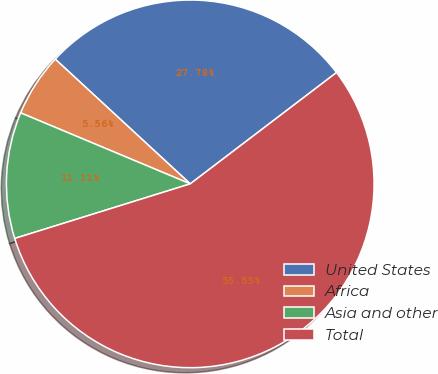Convert chart. <chart><loc_0><loc_0><loc_500><loc_500><pie_chart><fcel>United States<fcel>Africa<fcel>Asia and other<fcel>Total<nl><fcel>27.78%<fcel>5.56%<fcel>11.11%<fcel>55.56%<nl></chart> 